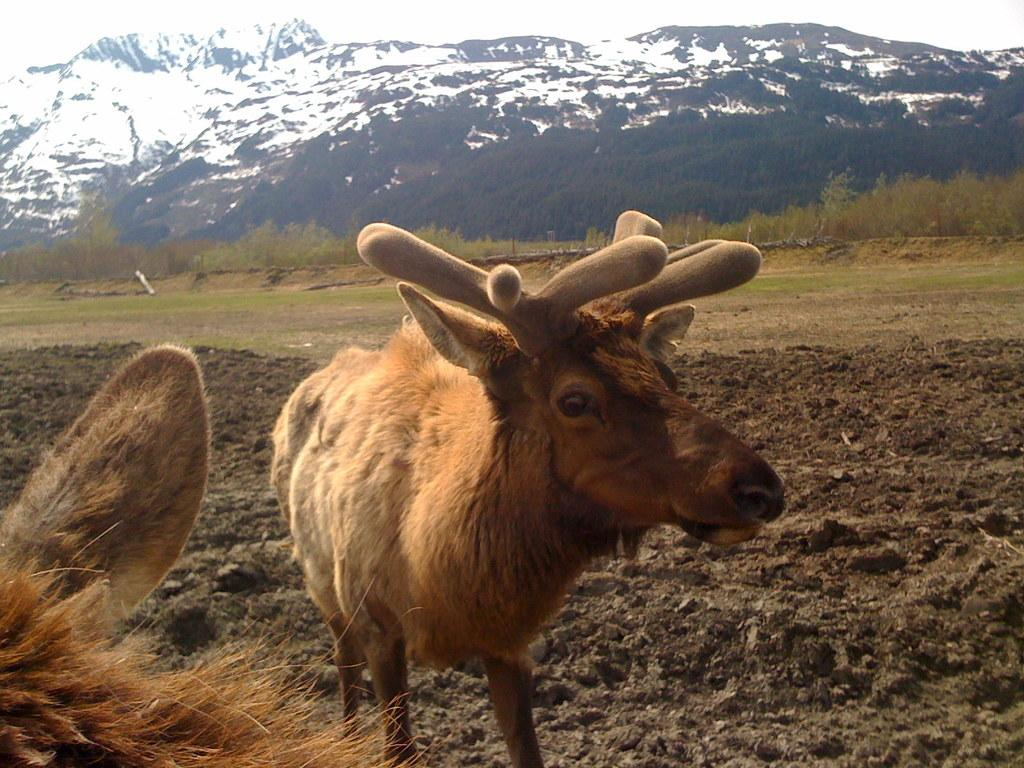What animal is in the picture? There is a reindeer in the in the picture. What is the reindeer doing in the picture? The reindeer is standing. What type of terrain is visible at the bottom of the picture? There is soil at the bottom of the picture. What can be seen in the background of the picture? There are trees in the background of the picture. What type of vegetation is present in the picture? There is grass in the picture. What type of clouds can be seen in the picture? There are no clouds visible in the picture; it features a reindeer standing on soil with trees in the background and grass in the foreground. 